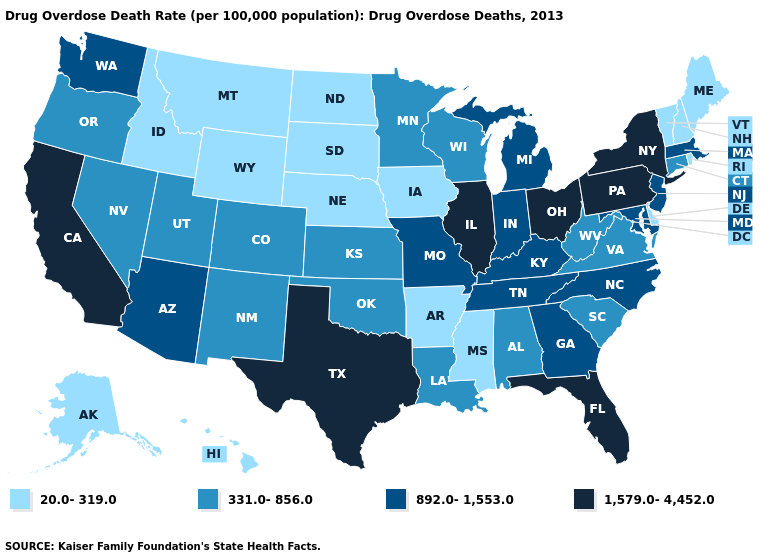What is the value of Mississippi?
Answer briefly. 20.0-319.0. Which states have the lowest value in the USA?
Write a very short answer. Alaska, Arkansas, Delaware, Hawaii, Idaho, Iowa, Maine, Mississippi, Montana, Nebraska, New Hampshire, North Dakota, Rhode Island, South Dakota, Vermont, Wyoming. Which states have the lowest value in the USA?
Concise answer only. Alaska, Arkansas, Delaware, Hawaii, Idaho, Iowa, Maine, Mississippi, Montana, Nebraska, New Hampshire, North Dakota, Rhode Island, South Dakota, Vermont, Wyoming. Does New York have a lower value than New Hampshire?
Be succinct. No. Does Iowa have the same value as Illinois?
Keep it brief. No. Which states have the lowest value in the West?
Quick response, please. Alaska, Hawaii, Idaho, Montana, Wyoming. What is the value of Louisiana?
Keep it brief. 331.0-856.0. What is the value of Minnesota?
Concise answer only. 331.0-856.0. Does the map have missing data?
Give a very brief answer. No. What is the value of Kansas?
Keep it brief. 331.0-856.0. Among the states that border California , which have the lowest value?
Answer briefly. Nevada, Oregon. Among the states that border Wyoming , which have the highest value?
Keep it brief. Colorado, Utah. What is the value of Oklahoma?
Give a very brief answer. 331.0-856.0. Which states have the highest value in the USA?
Answer briefly. California, Florida, Illinois, New York, Ohio, Pennsylvania, Texas. What is the highest value in the Northeast ?
Quick response, please. 1,579.0-4,452.0. 